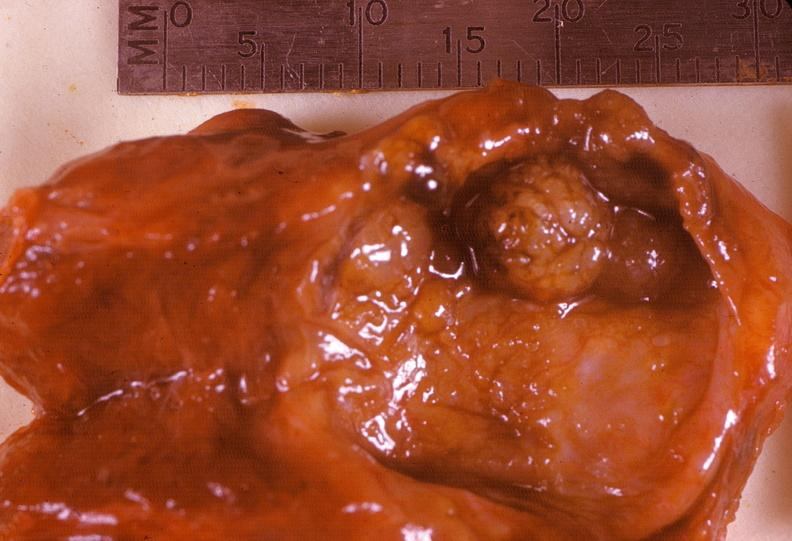where does this belong to?
Answer the question using a single word or phrase. Endocrine system 